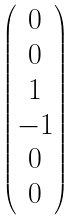<formula> <loc_0><loc_0><loc_500><loc_500>\begin{pmatrix} 0 \\ 0 \\ 1 \\ - 1 \\ 0 \\ 0 \end{pmatrix}</formula> 